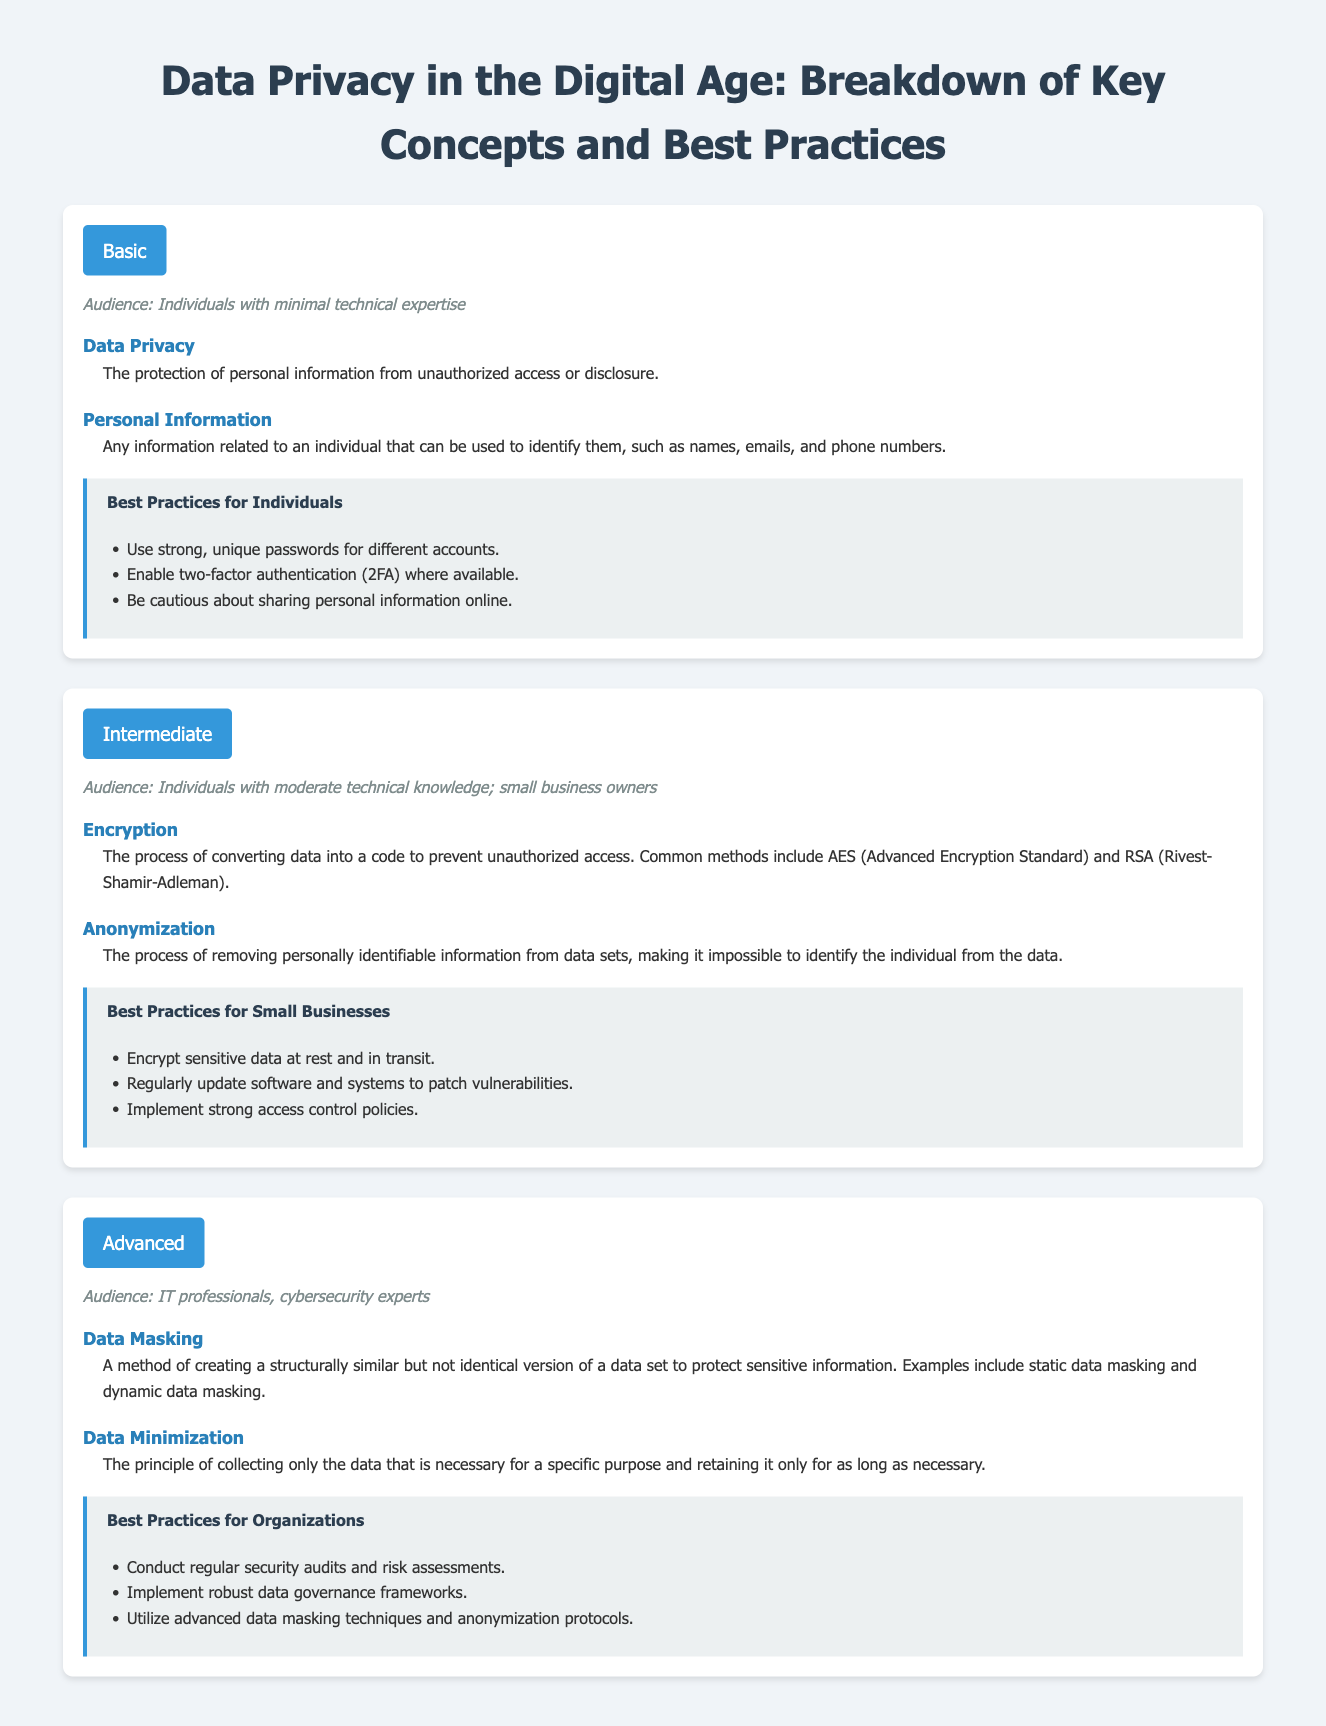what is the purpose of data privacy? Data privacy is the protection of personal information from unauthorized access or disclosure as stated in the document.
Answer: protection of personal information what is a common method of encryption mentioned? The document lists AES (Advanced Encryption Standard) as a common method of encryption.
Answer: AES what audience is targeted for the advanced level? The audience for the advanced level includes IT professionals and cybersecurity experts as specified in the content.
Answer: IT professionals, cybersecurity experts what is the definition of anonymization? Anonymization is defined in the document as the process of removing personally identifiable information from data sets.
Answer: removing personally identifiable information which practice is recommended for individuals regarding passwords? The document recommends using strong, unique passwords for different accounts as a best practice for individuals.
Answer: strong, unique passwords what are the two types of data masking mentioned? The types of data masking described in the document are static data masking and dynamic data masking.
Answer: static data masking, dynamic data masking how many best practices are listed for small businesses? There are three best practices listed for small businesses according to the document.
Answer: three what principle of data collection is outlined in the advanced section? The document outlines the principle of data minimization, which focuses on collecting only necessary data.
Answer: data minimization what is the audience for the basic level? The audience targeted for the basic level is individuals with minimal technical expertise as per the document.
Answer: individuals with minimal technical expertise 